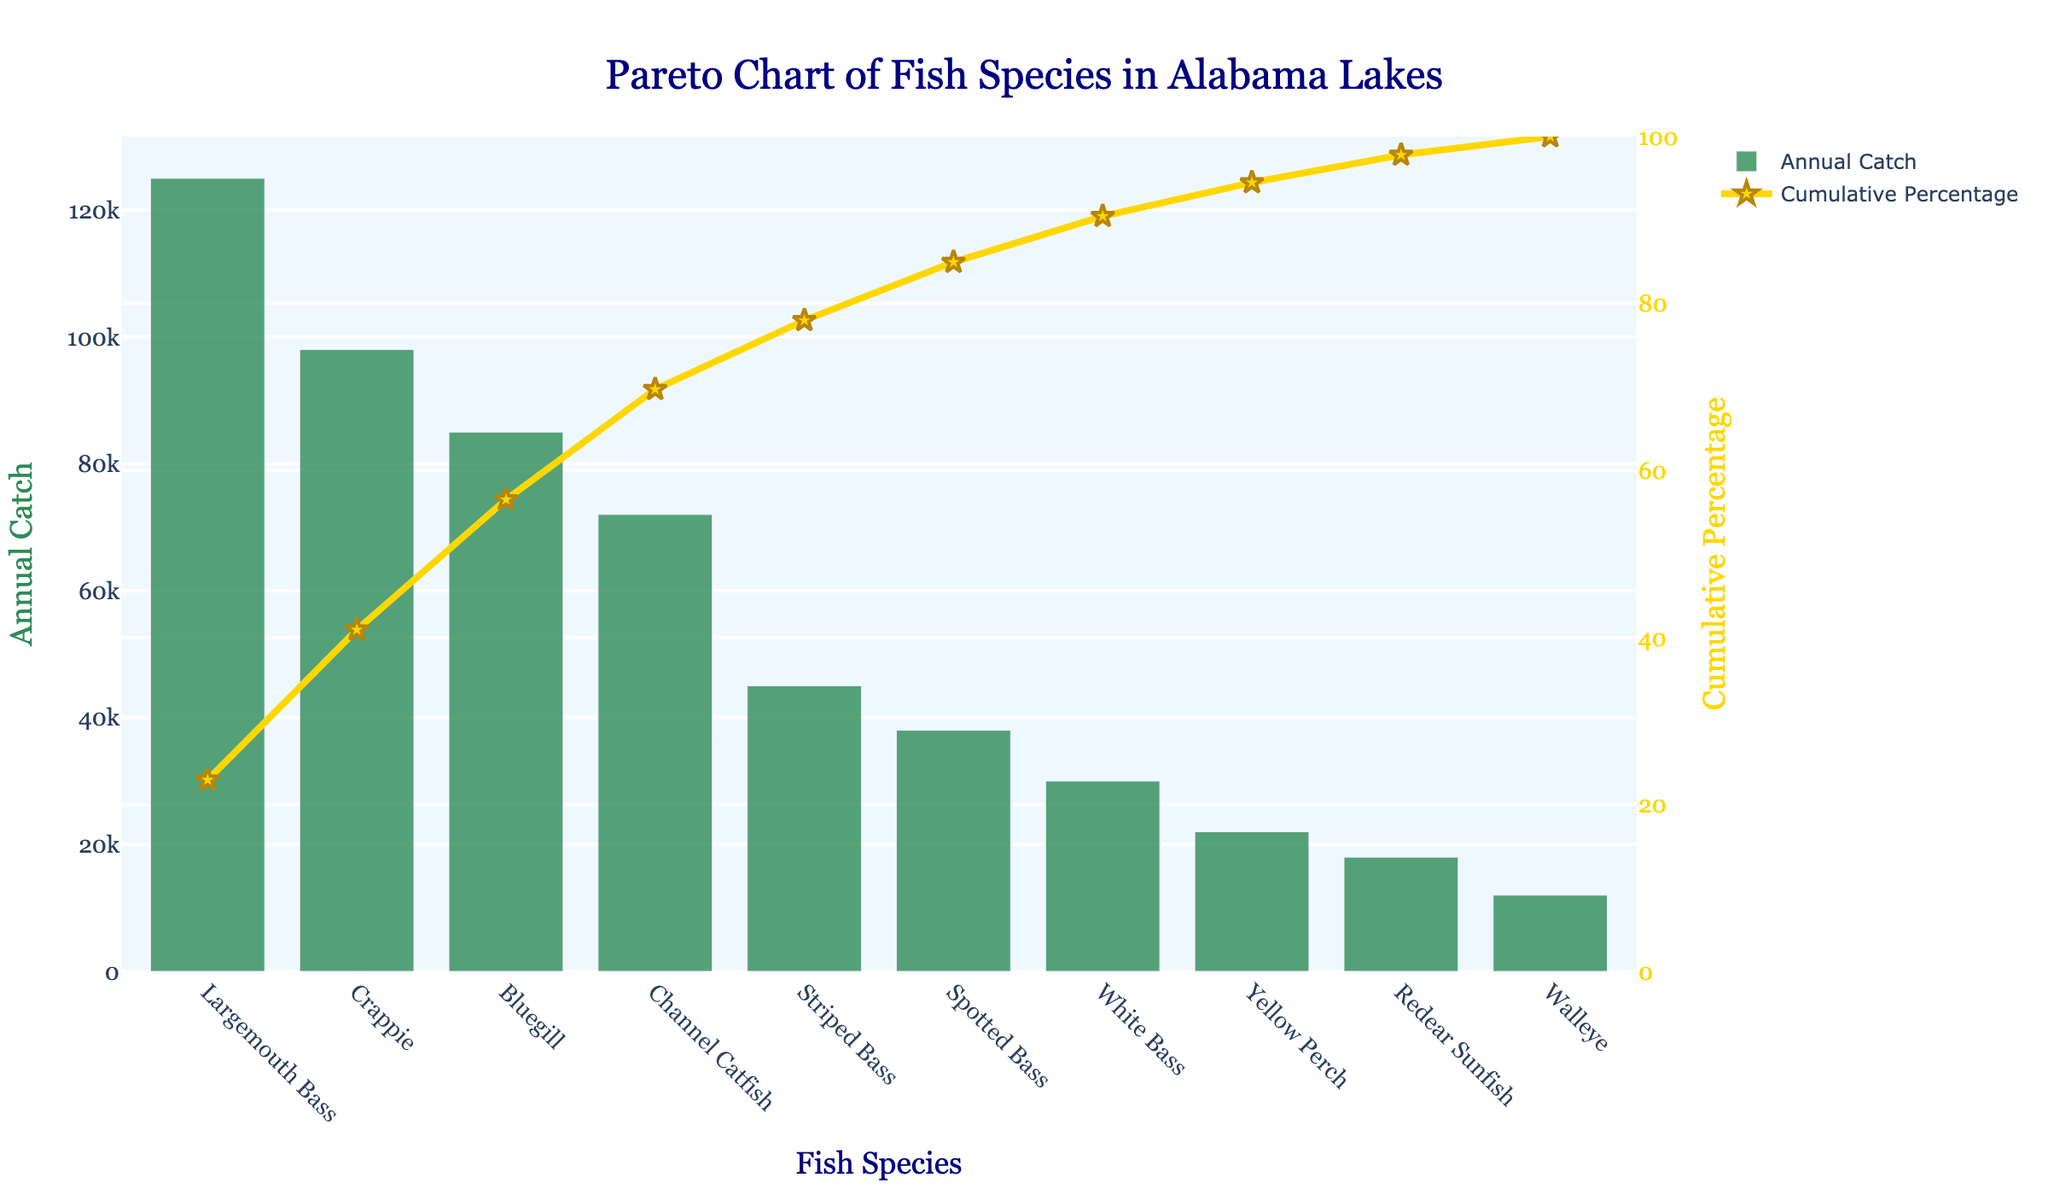What's the title of the chart? The title of the chart is displayed at the top and reads "Pareto Chart of Fish Species in Alabama Lakes".
Answer: Pareto Chart of Fish Species in Alabama Lakes What are the species with the highest and lowest annual catch numbers? The species with the highest annual catch is found at the far left of the x-axis ("Largemouth Bass"), and the species with the lowest annual catch is found at the far right of the x-axis ("Walleye").
Answer: Largemouth Bass, Walleye How many fish species have an annual catch greater than 50,000? The bar heights show the annual catch numbers. By comparing the heights to the value of 50,000, we see that "Largemouth Bass", "Crappie", "Bluegill", and "Channel Catfish" exceed this number.
Answer: 4 Which fish species contributes to over 80% of the cumulative percentage? The "Cumulative Percentage" line trace reaches over 80% after "Channel Catfish", which includes "Largemouth Bass", "Crappie", and "Bluegill" as well.
Answer: Largemouth Bass, Crappie, Bluegill, Channel Catfish What's the cumulative percentage at the 5th ranked fish species by catch? From the line trace, the cumulative percentage at the 5th ranked fish species, "Striped Bass", can be read directly from the y-axis on the right.
Answer: About 82.3% Which fish species have an annual catch number between 20,000 and 40,000? Looking at the bar heights that fall between 20,000 and 40,000 on the y-axis, the species are "Spotted Bass", "White Bass", and "Yellow Perch".
Answer: Spotted Bass, White Bass, Yellow Perch What species is caught at a rate closest to 10% of the total annual catches? From the cumulative percentage curve, "Channel Catfish" appears closest to 10%, as given by the line's intersection with the right y-axis.
Answer: Channel Catfish How does the annual catch of "Crappie" compare to "Bluegill"? The bar height for "Crappie" is higher than "Bluegill", indicating a higher annual catch number.
Answer: Crappie has a higher catch How much larger is the annual catch of "Largemouth Bass" compared to "Spotted Bass"? The annual catch data shows "Largemouth Bass" at 125,000 and "Spotted Bass" at 38,000. The difference is 125,000 - 38,000 = 87,000.
Answer: 87,000 If someone caught a "White Bass", how does its catch rate proportionally compare to "Largemouth Bass"? The catch number for "White Bass" is 30,000 and for "Largemouth Bass" is 125,000. The ratio is 30,000 / 125,000.
Answer: About 0.24 (24%) 